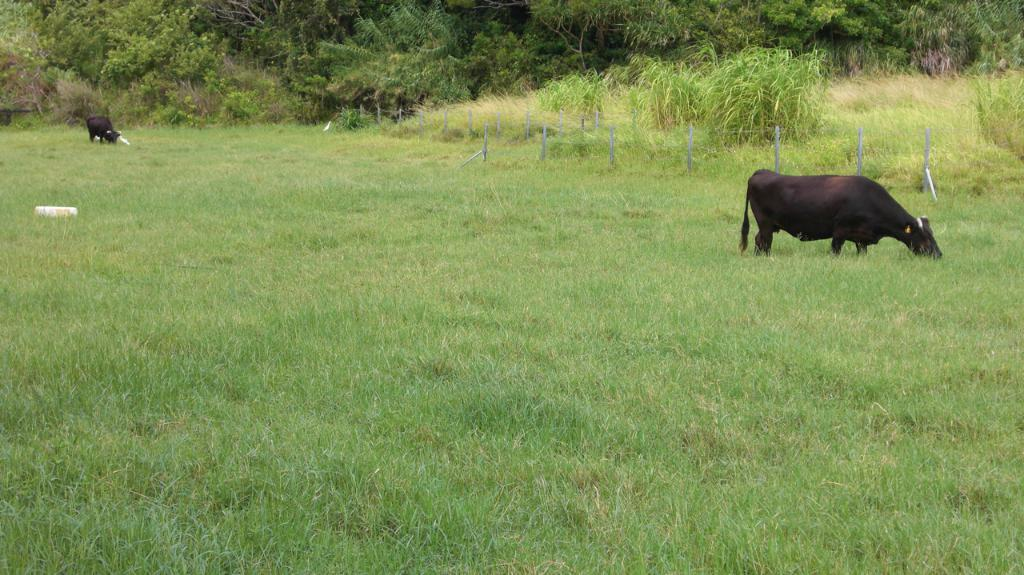What type of vegetation is present on the ground in the image? There is grass on the ground in the image. What animals can be seen in the image? There are cows in the image. What structures are present in the image? There are poles in the image. What can be seen in the distance in the image? There are trees in the background of the image. What type of education is being provided to the cows in the image? There is no indication in the image that the cows are receiving any education. 